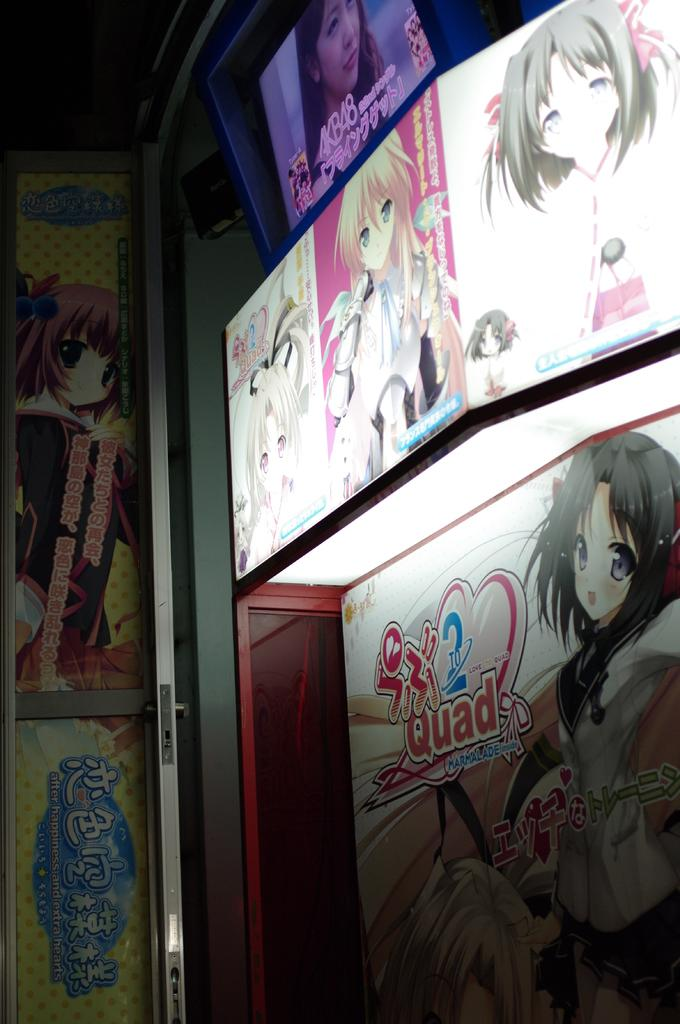What type of objects are present in the image? There are advertising boards in the image. What is depicted on the advertising boards? The advertising boards have an animation of persons. Are there any words or phrases on the advertising boards? Yes, there is text on the advertising boards. Where is the library located in the image? There is no library present in the image; it features advertising boards with an animation of persons and text. 